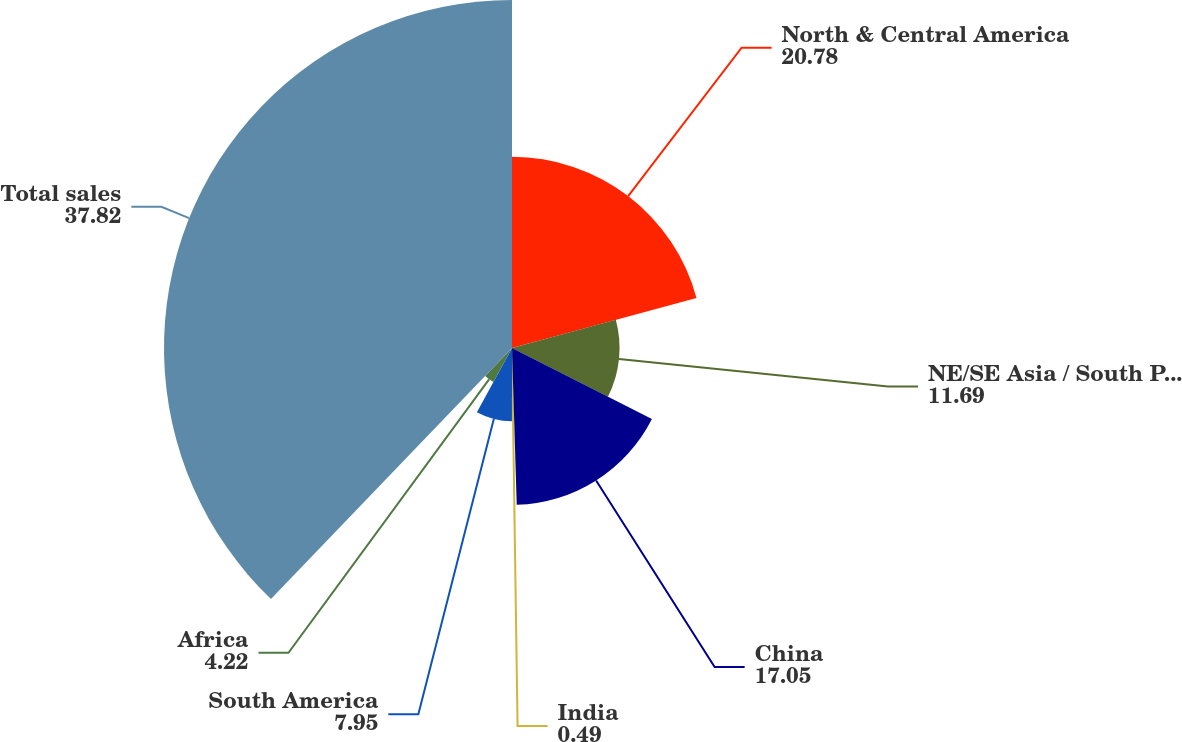Convert chart. <chart><loc_0><loc_0><loc_500><loc_500><pie_chart><fcel>North & Central America<fcel>NE/SE Asia / South Pacific<fcel>China<fcel>India<fcel>South America<fcel>Africa<fcel>Total sales<nl><fcel>20.78%<fcel>11.69%<fcel>17.05%<fcel>0.49%<fcel>7.95%<fcel>4.22%<fcel>37.82%<nl></chart> 